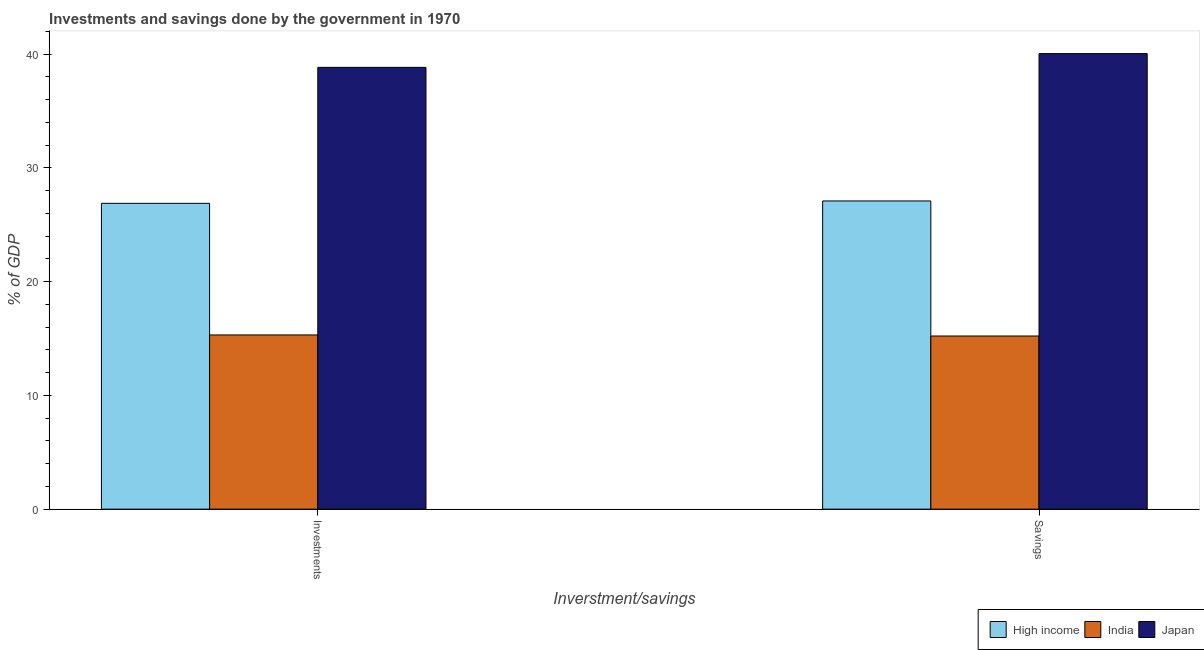How many different coloured bars are there?
Give a very brief answer. 3. Are the number of bars per tick equal to the number of legend labels?
Provide a short and direct response. Yes. How many bars are there on the 1st tick from the left?
Offer a very short reply. 3. What is the label of the 2nd group of bars from the left?
Give a very brief answer. Savings. What is the savings of government in India?
Your answer should be very brief. 15.22. Across all countries, what is the maximum savings of government?
Your answer should be compact. 40.05. Across all countries, what is the minimum savings of government?
Offer a terse response. 15.22. In which country was the savings of government maximum?
Provide a short and direct response. Japan. In which country was the savings of government minimum?
Give a very brief answer. India. What is the total savings of government in the graph?
Make the answer very short. 82.38. What is the difference between the savings of government in Japan and that in High income?
Make the answer very short. 12.96. What is the difference between the investments of government in Japan and the savings of government in India?
Offer a very short reply. 23.62. What is the average savings of government per country?
Your answer should be very brief. 27.46. What is the difference between the savings of government and investments of government in High income?
Provide a short and direct response. 0.21. In how many countries, is the savings of government greater than 40 %?
Provide a short and direct response. 1. What is the ratio of the savings of government in India to that in Japan?
Offer a very short reply. 0.38. Is the investments of government in India less than that in Japan?
Your answer should be compact. Yes. Are all the bars in the graph horizontal?
Your response must be concise. No. What is the difference between two consecutive major ticks on the Y-axis?
Your response must be concise. 10. Does the graph contain any zero values?
Ensure brevity in your answer.  No. How many legend labels are there?
Provide a succinct answer. 3. What is the title of the graph?
Provide a succinct answer. Investments and savings done by the government in 1970. What is the label or title of the X-axis?
Offer a terse response. Inverstment/savings. What is the label or title of the Y-axis?
Ensure brevity in your answer.  % of GDP. What is the % of GDP of High income in Investments?
Your response must be concise. 26.89. What is the % of GDP in India in Investments?
Provide a succinct answer. 15.32. What is the % of GDP of Japan in Investments?
Keep it short and to the point. 38.84. What is the % of GDP in High income in Savings?
Give a very brief answer. 27.1. What is the % of GDP of India in Savings?
Make the answer very short. 15.22. What is the % of GDP in Japan in Savings?
Offer a terse response. 40.05. Across all Inverstment/savings, what is the maximum % of GDP in High income?
Give a very brief answer. 27.1. Across all Inverstment/savings, what is the maximum % of GDP in India?
Provide a short and direct response. 15.32. Across all Inverstment/savings, what is the maximum % of GDP in Japan?
Offer a terse response. 40.05. Across all Inverstment/savings, what is the minimum % of GDP of High income?
Provide a short and direct response. 26.89. Across all Inverstment/savings, what is the minimum % of GDP of India?
Keep it short and to the point. 15.22. Across all Inverstment/savings, what is the minimum % of GDP in Japan?
Your response must be concise. 38.84. What is the total % of GDP of High income in the graph?
Offer a terse response. 53.99. What is the total % of GDP in India in the graph?
Keep it short and to the point. 30.54. What is the total % of GDP in Japan in the graph?
Give a very brief answer. 78.9. What is the difference between the % of GDP in High income in Investments and that in Savings?
Provide a succinct answer. -0.21. What is the difference between the % of GDP in India in Investments and that in Savings?
Ensure brevity in your answer.  0.09. What is the difference between the % of GDP in Japan in Investments and that in Savings?
Give a very brief answer. -1.21. What is the difference between the % of GDP of High income in Investments and the % of GDP of India in Savings?
Make the answer very short. 11.67. What is the difference between the % of GDP of High income in Investments and the % of GDP of Japan in Savings?
Your answer should be compact. -13.16. What is the difference between the % of GDP of India in Investments and the % of GDP of Japan in Savings?
Make the answer very short. -24.74. What is the average % of GDP of High income per Inverstment/savings?
Offer a terse response. 26.99. What is the average % of GDP of India per Inverstment/savings?
Offer a terse response. 15.27. What is the average % of GDP in Japan per Inverstment/savings?
Your answer should be compact. 39.45. What is the difference between the % of GDP of High income and % of GDP of India in Investments?
Ensure brevity in your answer.  11.57. What is the difference between the % of GDP in High income and % of GDP in Japan in Investments?
Your response must be concise. -11.95. What is the difference between the % of GDP in India and % of GDP in Japan in Investments?
Provide a short and direct response. -23.53. What is the difference between the % of GDP of High income and % of GDP of India in Savings?
Provide a short and direct response. 11.88. What is the difference between the % of GDP in High income and % of GDP in Japan in Savings?
Your response must be concise. -12.96. What is the difference between the % of GDP in India and % of GDP in Japan in Savings?
Offer a very short reply. -24.83. What is the ratio of the % of GDP of High income in Investments to that in Savings?
Your answer should be compact. 0.99. What is the ratio of the % of GDP in Japan in Investments to that in Savings?
Provide a succinct answer. 0.97. What is the difference between the highest and the second highest % of GDP of High income?
Your answer should be very brief. 0.21. What is the difference between the highest and the second highest % of GDP of India?
Provide a short and direct response. 0.09. What is the difference between the highest and the second highest % of GDP of Japan?
Give a very brief answer. 1.21. What is the difference between the highest and the lowest % of GDP in High income?
Provide a short and direct response. 0.21. What is the difference between the highest and the lowest % of GDP in India?
Make the answer very short. 0.09. What is the difference between the highest and the lowest % of GDP of Japan?
Your answer should be compact. 1.21. 